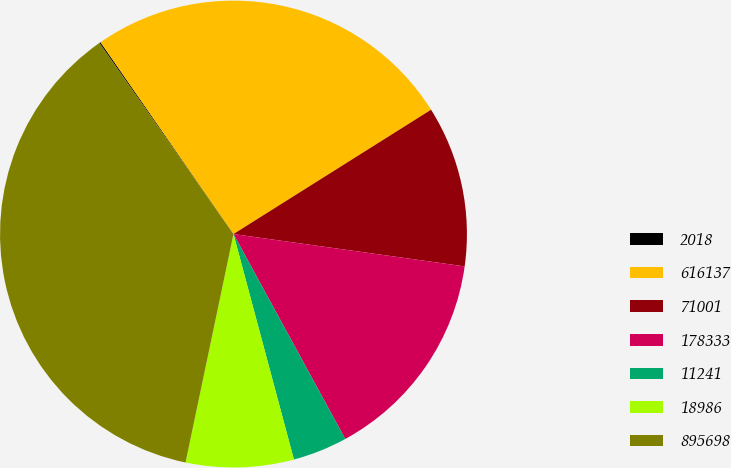Convert chart. <chart><loc_0><loc_0><loc_500><loc_500><pie_chart><fcel>2018<fcel>616137<fcel>71001<fcel>178333<fcel>11241<fcel>18986<fcel>895698<nl><fcel>0.09%<fcel>25.71%<fcel>11.15%<fcel>14.84%<fcel>3.78%<fcel>7.46%<fcel>36.97%<nl></chart> 